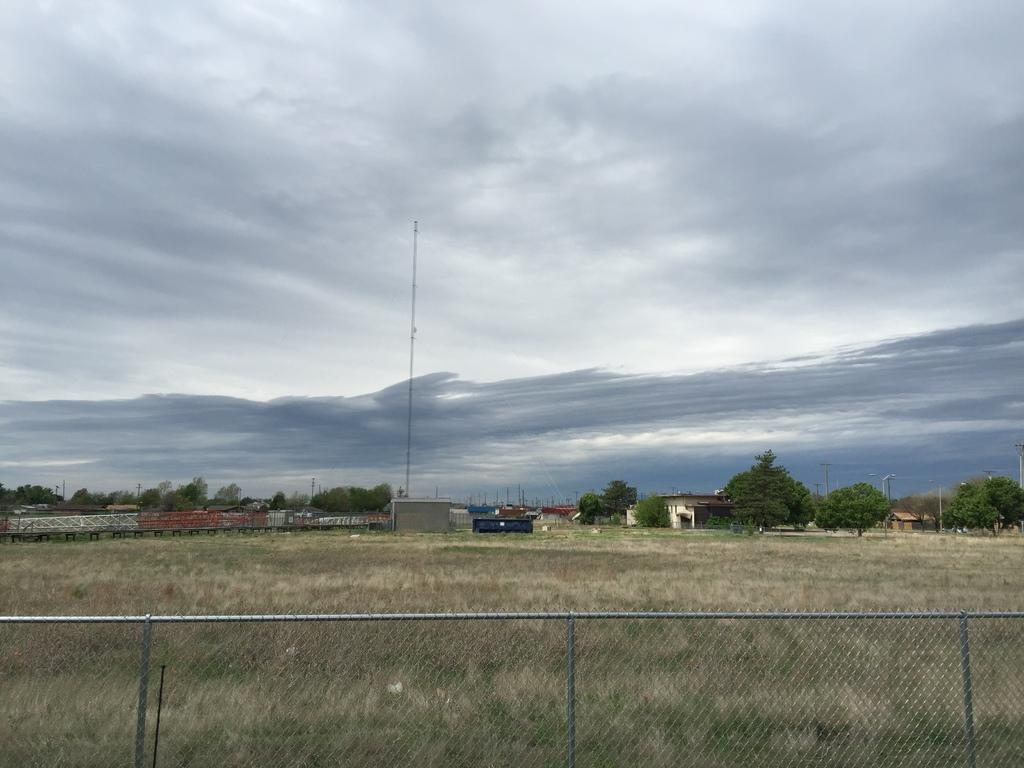Can you describe this image briefly? At the bottom of the image there is fencing. Behind the fencing there's grass on the ground. In the background there are trees, buildings, poles and some other objects. At the top of the image there is sky with clouds. 